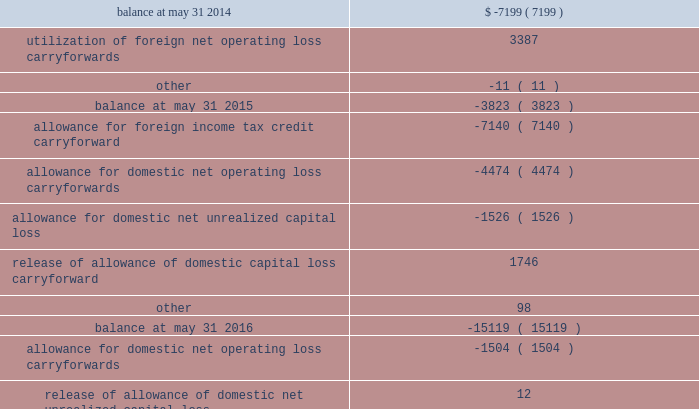A valuation allowance is provided against deferred tax assets when it is more likely than not that some portion or all of the deferred tax assets will not be realized .
Changes to our valuation allowance during the year ended december 31 , 2017 , the 2016 fiscal transition period and the years ended may 31 , 2016 and 2015 are summarized below ( in thousands ) : .
The increase in the valuation allowance related to net operating loss carryforwards of $ 10.3 million for the year ended december 31 , 2017 relates primarily to carryforward assets recorded as part of the acquisition of active network .
The increase in the valuation allowance related to domestic net operating loss carryforwards of $ 1.5 million and $ 4.5 million for the 2016 fiscal transition period and the year ended may 31 , 2016 , respectively , relates to acquired carryforwards from the merger with heartland .
Foreign net operating loss carryforwards of $ 43.2 million and domestic net operating loss carryforwards of $ 28.9 million at december 31 , 2017 will expire between december 31 , 2026 and december 31 , 2037 if not utilized .
We conduct business globally and file income tax returns in the domestic federal jurisdiction and various state and foreign jurisdictions .
In the normal course of business , we are subject to examination by taxing authorities around the world .
We are no longer subjected to state income tax examinations for years ended on or before may 31 , 2008 , u.s .
Federal income tax examinations for years ended on or before december 31 , 2013 and u.k .
Federal income tax examinations for years ended on or before may 31 , 2014 .
88 2013 global payments inc .
| 2017 form 10-k annual report .
What was the net change in the valuation allowance in thousands between 2016 and 2017? 
Computations: (-16550 - -16611)
Answer: 61.0. 